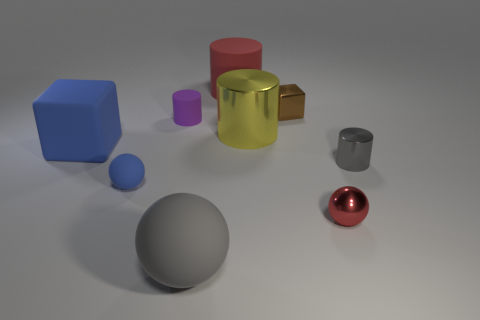What is the shape of the gray object to the right of the brown metallic object?
Keep it short and to the point. Cylinder. Are there fewer red cylinders than small cyan metal blocks?
Give a very brief answer. No. Is the big object to the left of the big rubber ball made of the same material as the small purple cylinder?
Offer a very short reply. Yes. Are there any other things that have the same size as the brown object?
Keep it short and to the point. Yes. Are there any big yellow shiny things on the right side of the red sphere?
Your response must be concise. No. The big cylinder in front of the matte object right of the matte sphere that is in front of the tiny red object is what color?
Your answer should be very brief. Yellow. The gray rubber object that is the same size as the blue block is what shape?
Offer a very short reply. Sphere. Is the number of big spheres greater than the number of small yellow rubber cubes?
Your answer should be very brief. Yes. Is there a yellow thing to the right of the metal cylinder that is behind the gray cylinder?
Your response must be concise. No. What color is the other tiny object that is the same shape as the purple thing?
Your answer should be compact. Gray. 